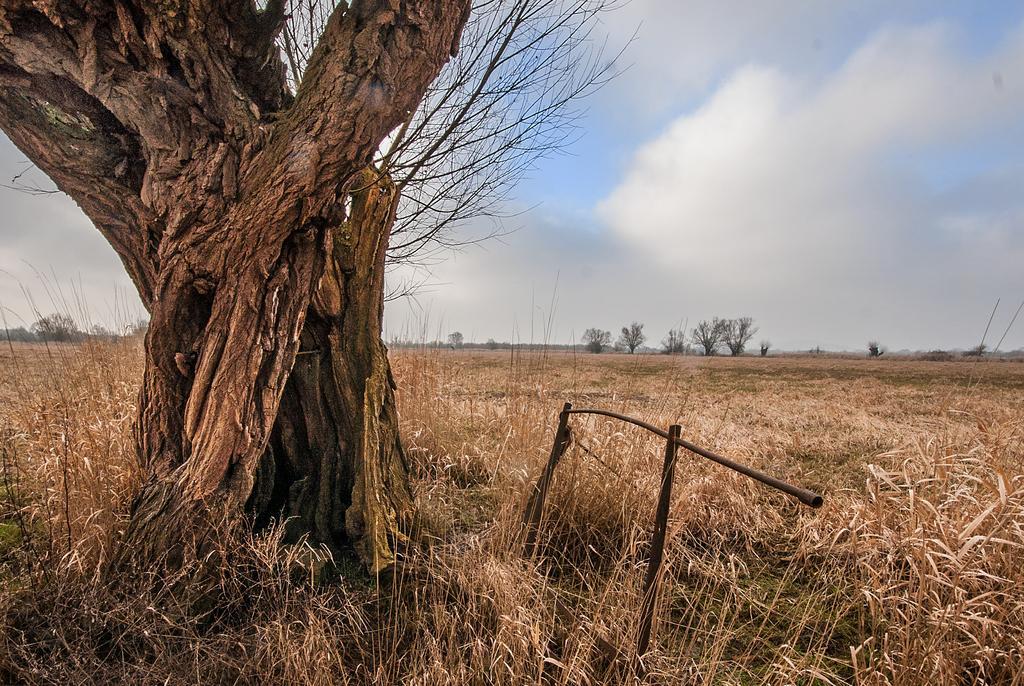How would you summarize this image in a sentence or two? In this image we can see the tree trunk and the rod and there are trees, grass and the cloudy sky. 